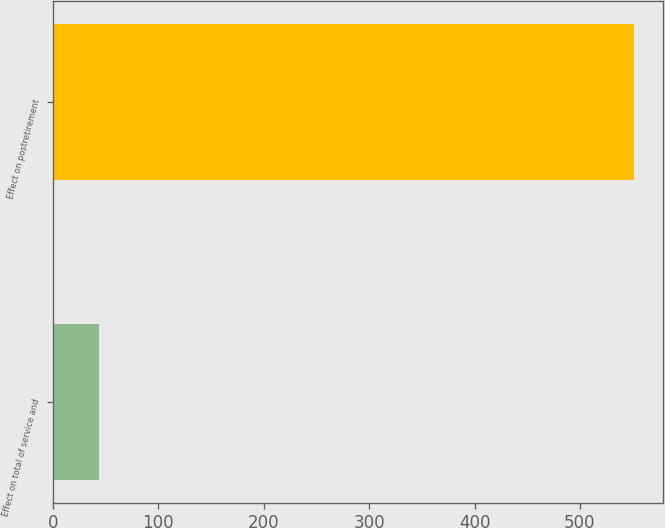Convert chart. <chart><loc_0><loc_0><loc_500><loc_500><bar_chart><fcel>Effect on total of service and<fcel>Effect on postretirement<nl><fcel>44<fcel>551<nl></chart> 